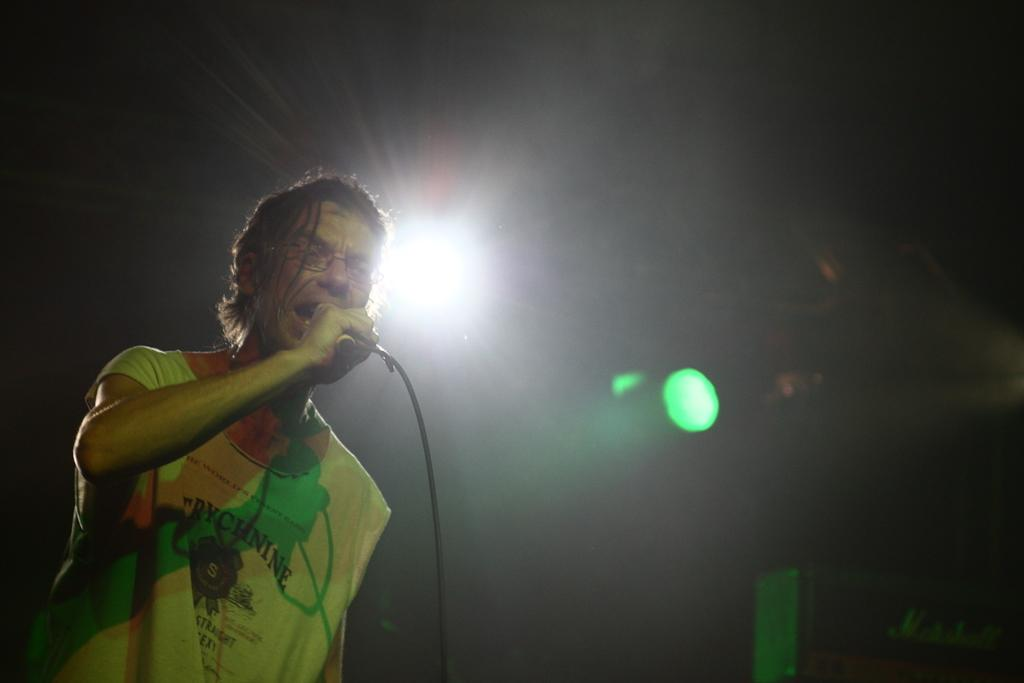Who is the main subject in the image? There is a man in the image. What is the man holding in the image? The man is holding a mic. What can be seen in the background of the image? There are lights visible in the background of the image. Reasoning: Let' Let's think step by step in order to produce the conversation. We start by identifying the main subject in the image, which is the man. Then, we expand the conversation to include what the man is holding, which is a mic. Finally, we describe the background of the image, which features lights. Each question is designed to elicit a specific detail about the image that is known from the provided facts. Absurd Question/Answer: What type of advice can be heard coming from the shade in the image? There is no shade present in the image, and therefore no advice can be heard coming from it. 